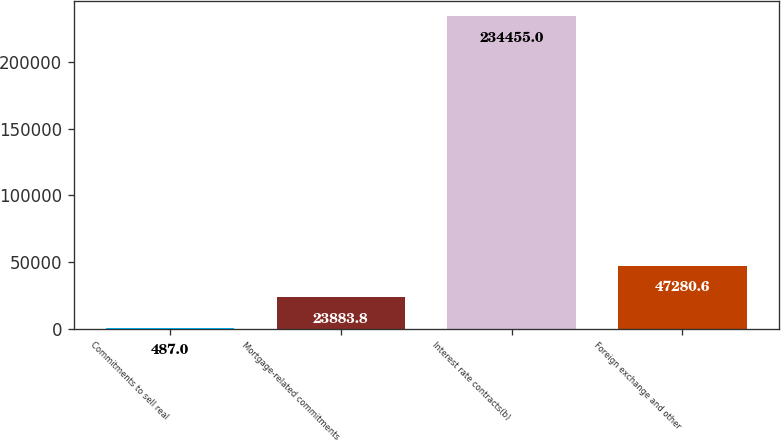Convert chart. <chart><loc_0><loc_0><loc_500><loc_500><bar_chart><fcel>Commitments to sell real<fcel>Mortgage-related commitments<fcel>Interest rate contracts(b)<fcel>Foreign exchange and other<nl><fcel>487<fcel>23883.8<fcel>234455<fcel>47280.6<nl></chart> 